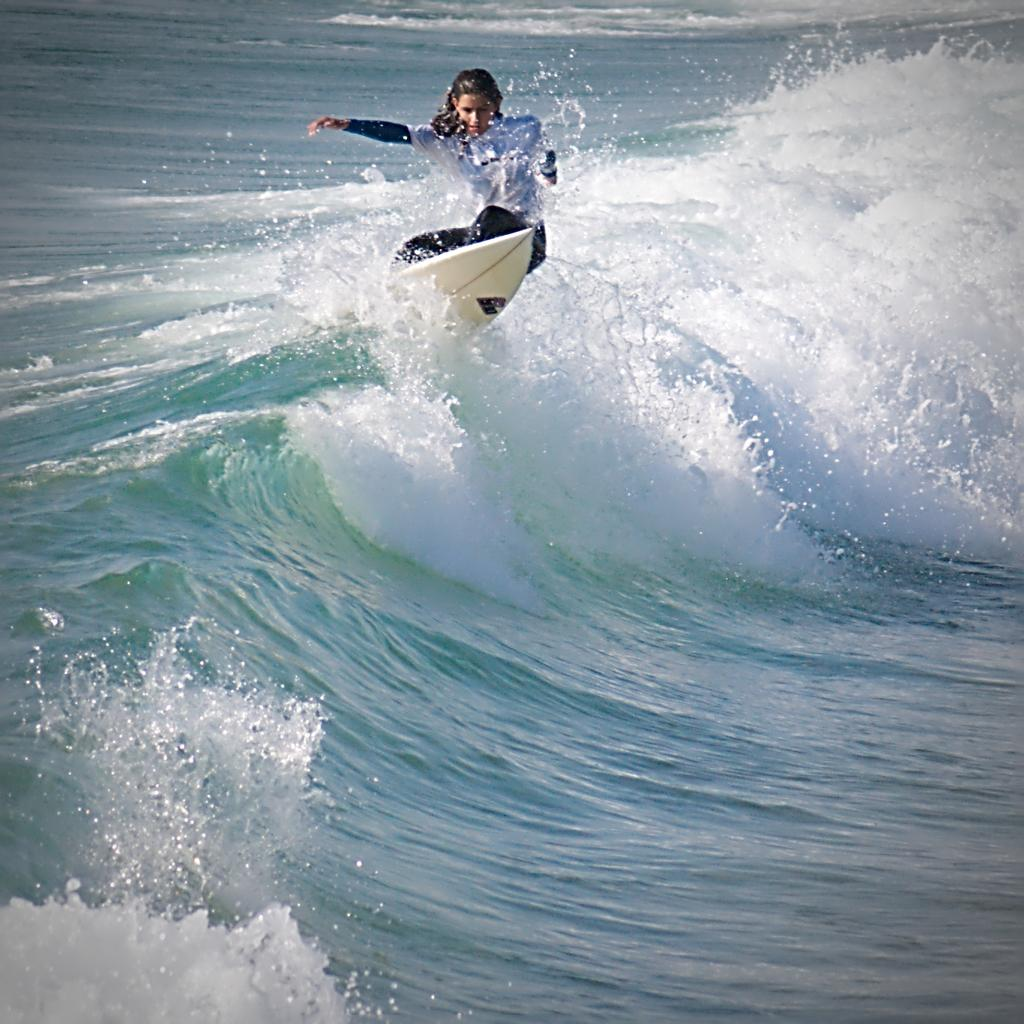Who is the main subject in the image? There is a girl in the image. What is the girl wearing? The girl is wearing a white and black costume. What activity is the girl engaged in? The girl is doing surfing on a board. Where is the surfing taking place? The surfing is taking place on sea water. What can be seen in the background of the image? There are water waves visible in the background. Is the girl in the image a representative of a political party? There is no information in the image to suggest that the girl is a representative of a political party. Does the skirt in the image have any existence? The girl is wearing a costume, not a skirt, so there is no skirt in the image. 